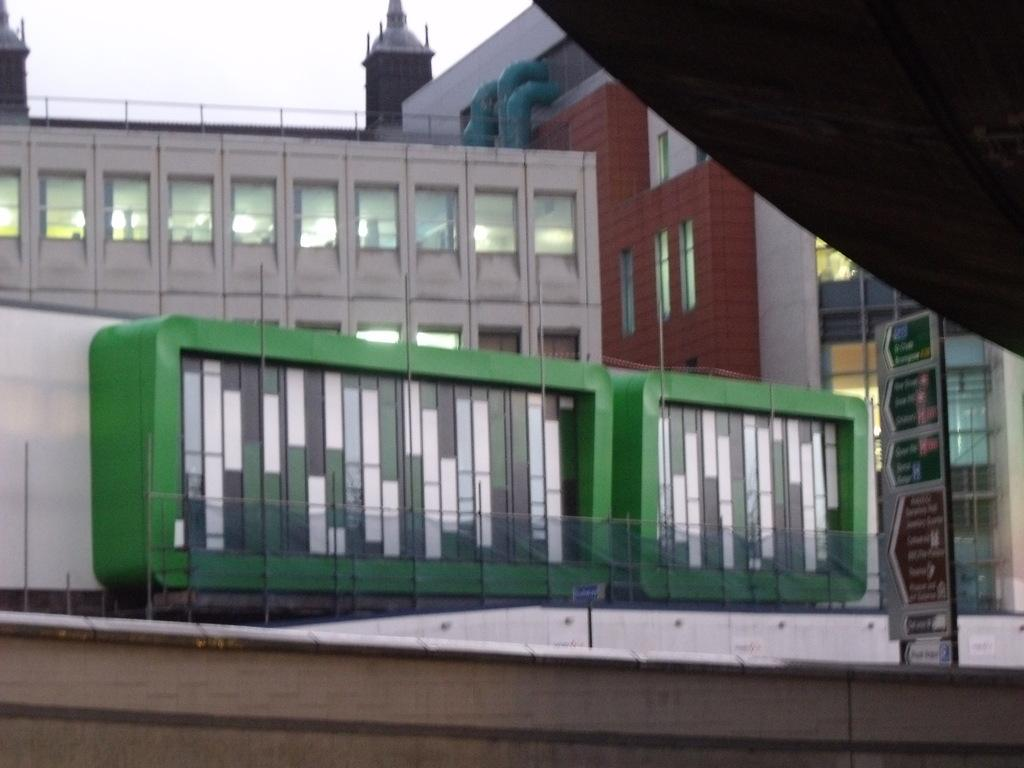What structures are located in the middle of the image? There are buildings in the middle of the image. What can be seen on the right side of the image? There is a board on the right side of the image. What is visible at the top of the image? The sky is visible at the top of the image. Can you tell me how many clovers are growing on the board in the image? There are no clovers present on the board in the image. What direction is the wind blowing in the image? There is no indication of wind in the image. 